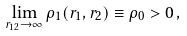<formula> <loc_0><loc_0><loc_500><loc_500>\lim _ { r _ { 1 2 } \rightarrow \infty } \rho _ { 1 } ( { r } _ { 1 } , { r } _ { 2 } ) \equiv \rho _ { 0 } > 0 \, ,</formula> 